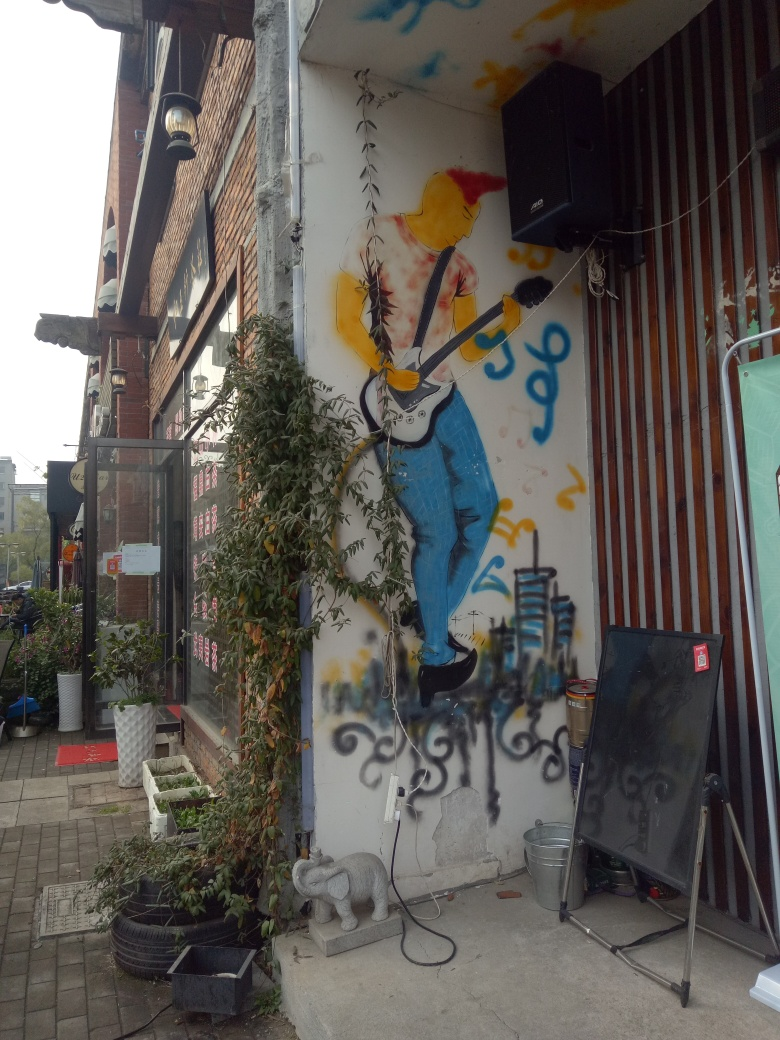What is the overall clarity of the image?
A. Moderate
B. Average
C. Very high
D. Low The clarity of the image can be considered very high, as the details are sharp and the colors are vivid. The street art depicted is well-resolved, allowing for clear observation of the textures and brush strokes, and there is no apparent blurriness or distortion that would indicate low quality. The surrounding objects, including plants, speaker, and various items on the floor, are also easily distinguishable, which supports the image's high clarity. 